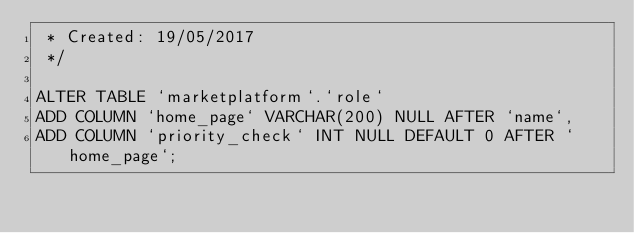<code> <loc_0><loc_0><loc_500><loc_500><_SQL_> * Created: 19/05/2017
 */

ALTER TABLE `marketplatform`.`role` 
ADD COLUMN `home_page` VARCHAR(200) NULL AFTER `name`,
ADD COLUMN `priority_check` INT NULL DEFAULT 0 AFTER `home_page`;
</code> 